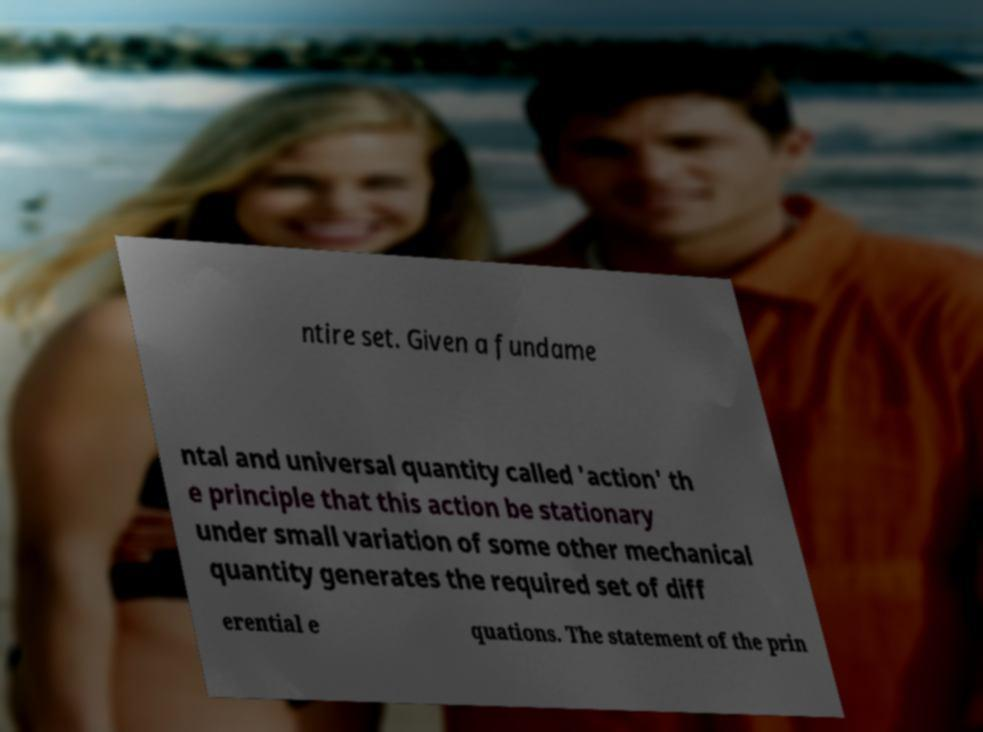Can you read and provide the text displayed in the image?This photo seems to have some interesting text. Can you extract and type it out for me? ntire set. Given a fundame ntal and universal quantity called 'action' th e principle that this action be stationary under small variation of some other mechanical quantity generates the required set of diff erential e quations. The statement of the prin 